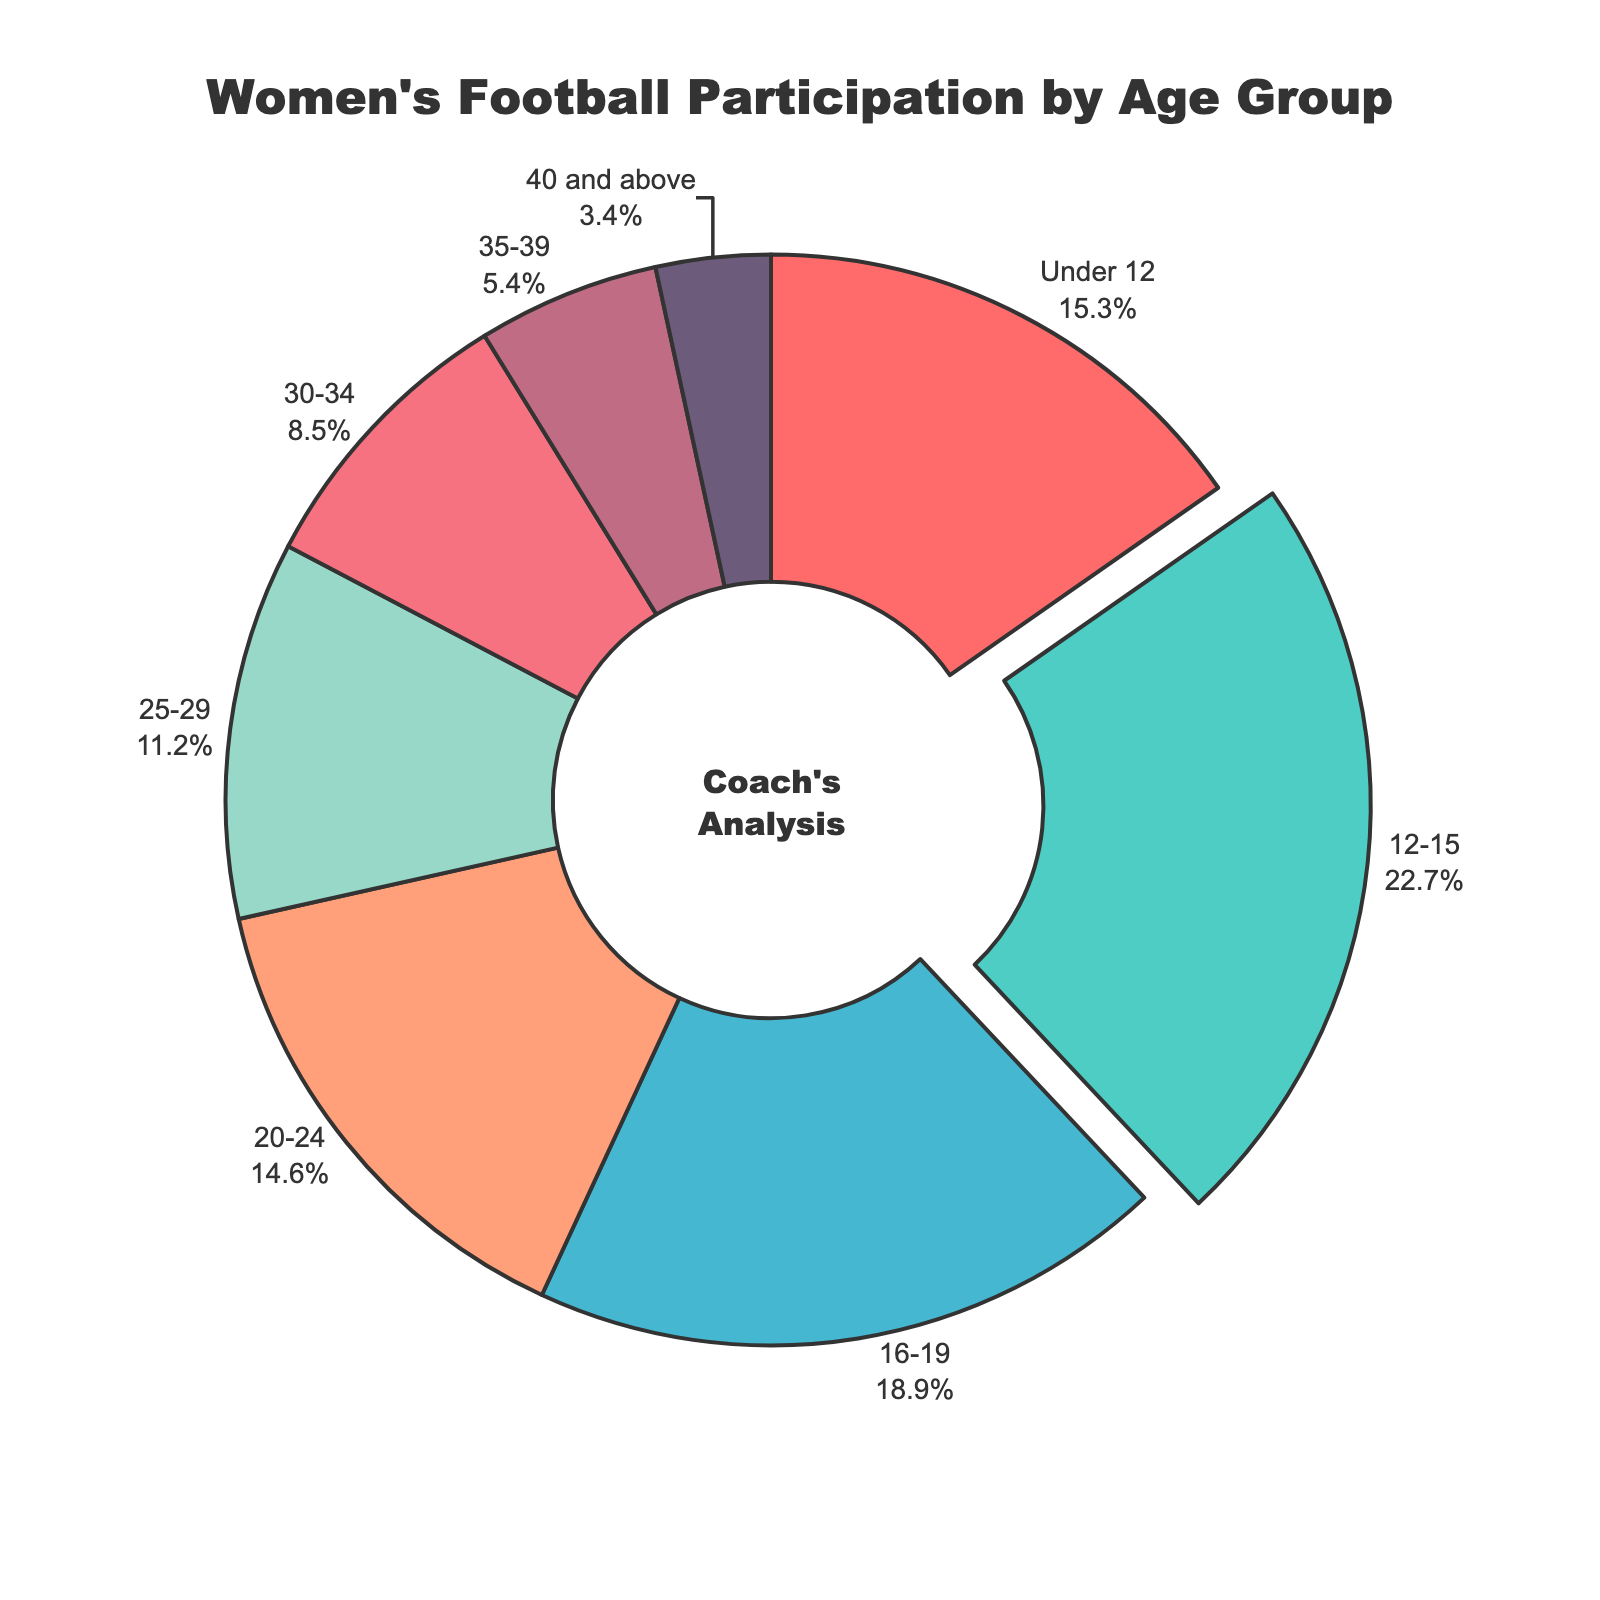What age group has the highest participation percentage in women's football? The pie chart shows the percentages of different age groups. By observing the segments, the largest segment represents the 12-15 age group with 22.7%.
Answer: 12-15 What is the total participation percentage for players aged under 12 and 16-19 combined? Add the percentages of the 'Under 12' group (15.3%) and '16-19' group (18.9%) together: 15.3% + 18.9% = 34.2%
Answer: 34.2% Which age group has the smallest participation percentage, and what is the value? The pie chart shows various percentages, and the smallest segment is the '40 and above' group at 3.4%.
Answer: 40 and above, 3.4% How much higher is the participation percentage of the 12-15 age group compared to the 30-34 age group? Subtract the percentage of the '30-34' group (8.5%) from the '12-15' group (22.7%): 22.7% - 8.5% = 14.2%
Answer: 14.2% What percentage of participants are over the age of 30 (30 and above)? Add the percentages of the '30-34' (8.5%), '35-39' (5.4%), and '40 and above' (3.4%) groups: 8.5% + 5.4% + 3.4% = 17.3%
Answer: 17.3% Which age group is represented by the red color in the pie chart? The pie chart uses a specific color pattern. The red color (first segment) represents the 'Under 12' age group.
Answer: Under 12 How does the participation of the 20-24 age group compare to the 25-29 age group? The '20-24' group has a participation rate of 14.6%, and the '25-29' group has 11.2%. The '20-24' group has a higher participation rate.
Answer: 20-24 > 25-29 What would be the median age group if the age groups were ordered by the percentage of participation? Ordering age groups by percentage: 12-15 (22.7%), 16-19 (18.9%), Under 12 (15.3%), 20-24 (14.6%), 25-29 (11.2%), 30-34 (8.5%), 35-39 (5.4%), 40 and above (3.4%). The middle values are 20-24 and 25-29; their median value is (14.6% + 11.2%) / 2 = 12.9%. The corresponding median age groups in this case are '20-24' and '25-29'.
Answer: 20-24 and 25-29 What is the difference between the participation percentage of the 'Under 12' and '35-39' age groups? Subtract the '35-39' group percentage (5.4%) from the 'Under 12' group percentage (15.3%): 15.3% - 5.4% = 9.9%.
Answer: 9.9% 